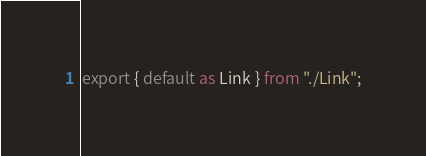Convert code to text. <code><loc_0><loc_0><loc_500><loc_500><_TypeScript_>export { default as Link } from "./Link";
</code> 